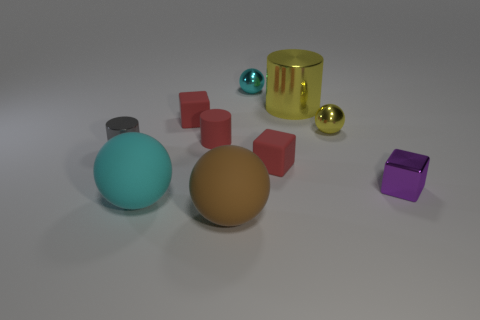Subtract all tiny matte cubes. How many cubes are left? 1 Subtract all yellow spheres. How many spheres are left? 3 Subtract all balls. How many objects are left? 6 Subtract 0 green blocks. How many objects are left? 10 Subtract 3 spheres. How many spheres are left? 1 Subtract all green balls. Subtract all blue blocks. How many balls are left? 4 Subtract all brown cylinders. How many cyan balls are left? 2 Subtract all tiny brown shiny cubes. Subtract all shiny cylinders. How many objects are left? 8 Add 9 large yellow metallic cylinders. How many large yellow metallic cylinders are left? 10 Add 7 yellow cylinders. How many yellow cylinders exist? 8 